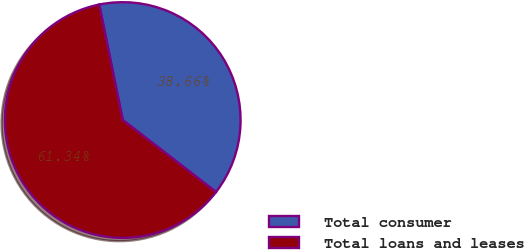<chart> <loc_0><loc_0><loc_500><loc_500><pie_chart><fcel>Total consumer<fcel>Total loans and leases<nl><fcel>38.66%<fcel>61.34%<nl></chart> 